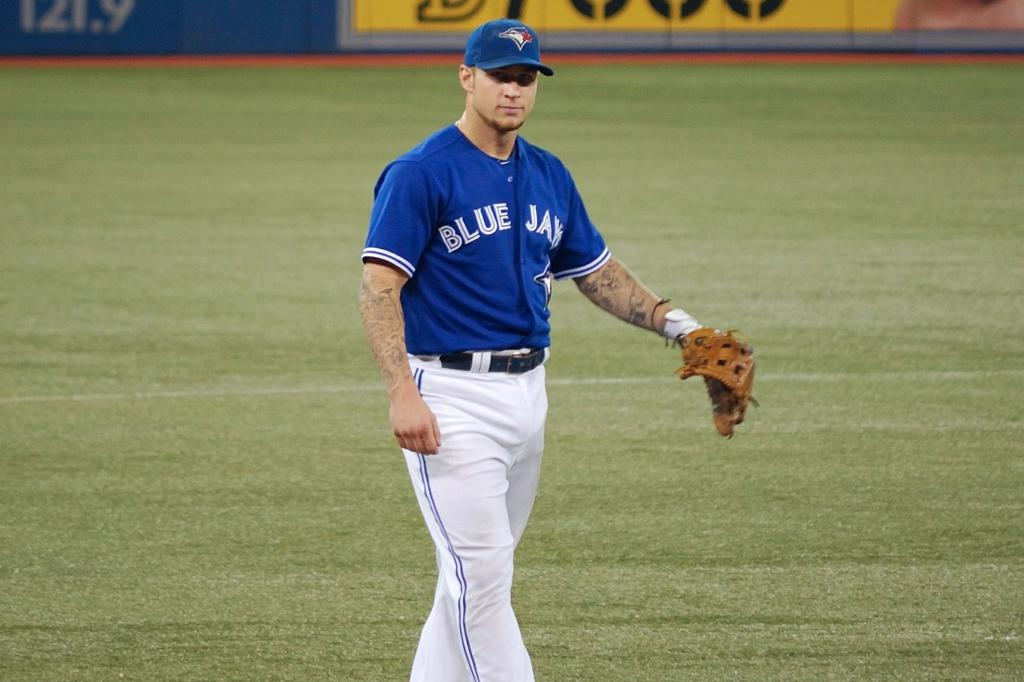<image>
Render a clear and concise summary of the photo. Baseball player in the outfield who plays for the Toronto Blue Jays. 